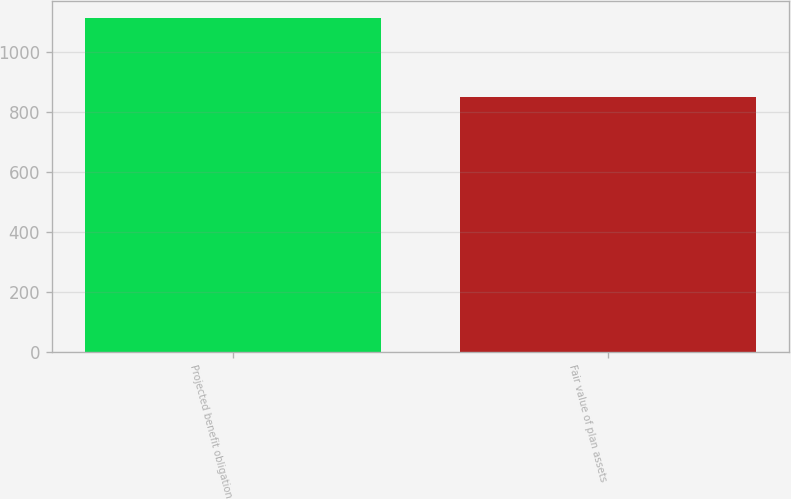Convert chart. <chart><loc_0><loc_0><loc_500><loc_500><bar_chart><fcel>Projected benefit obligation<fcel>Fair value of plan assets<nl><fcel>1114<fcel>851<nl></chart> 